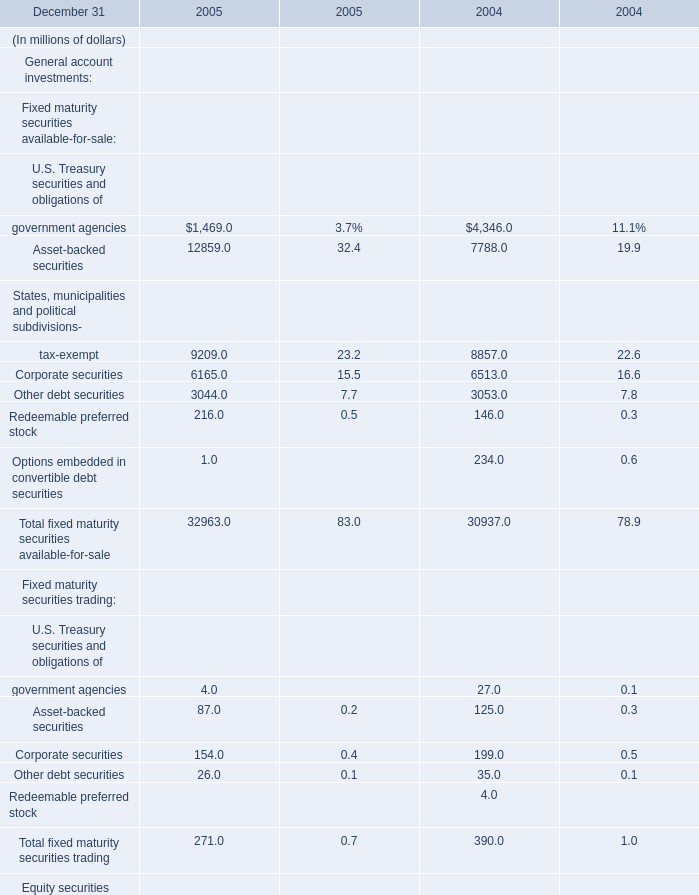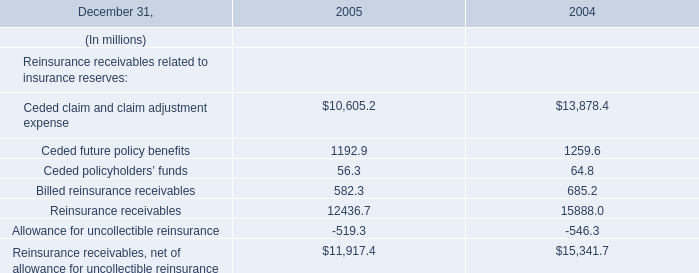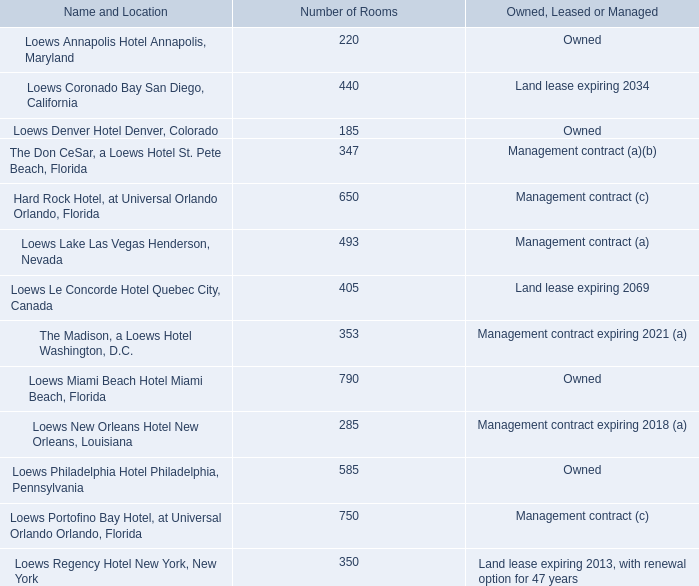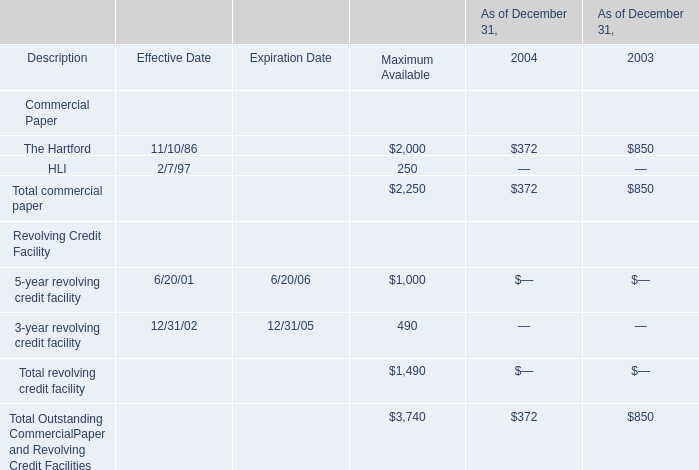What is the sum of the Total fixed maturity securities available-for-sale in the years where government agencies is positive? (in million) 
Computations: (32963.0 + 30937.0)
Answer: 63900.0. 